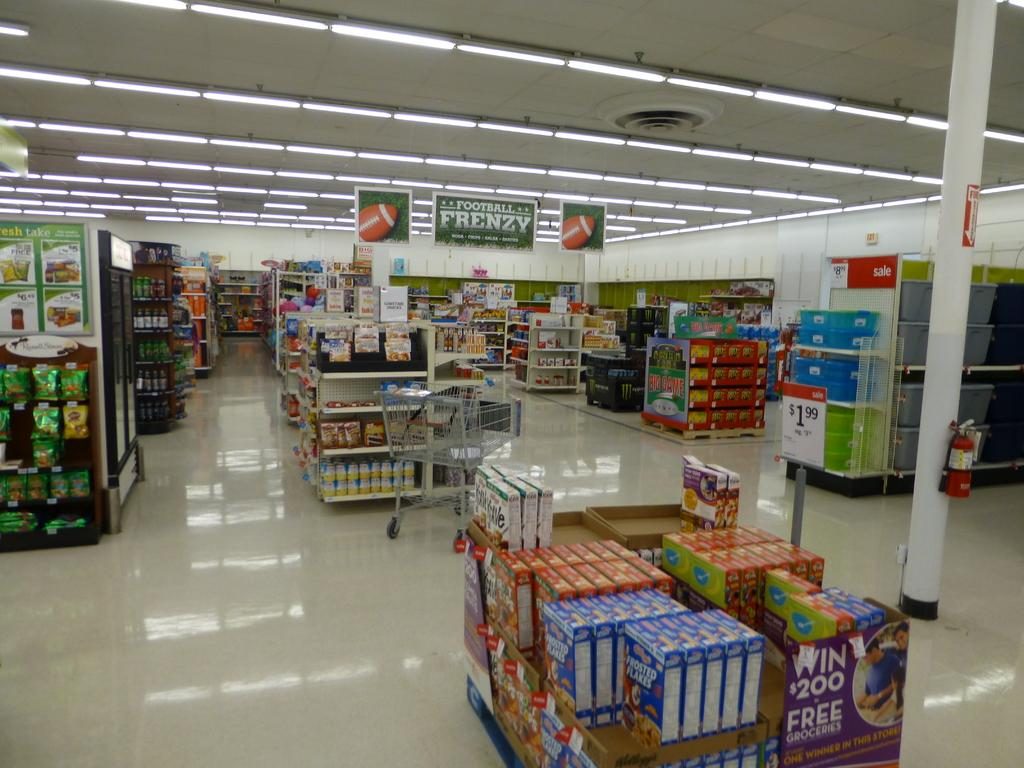Provide a one-sentence caption for the provided image. A football frenzy sign hangs in an aisle at a grocery store. 